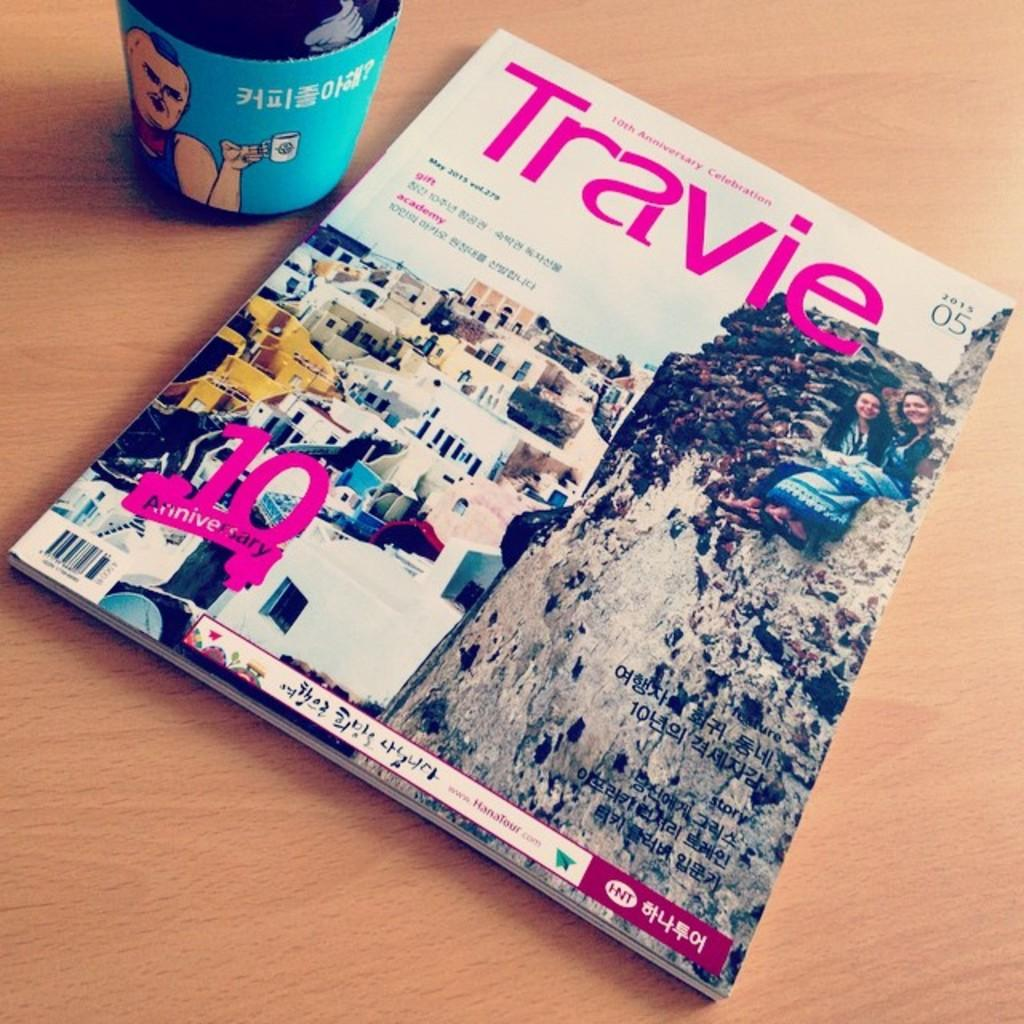<image>
Summarize the visual content of the image. Book titled Travie showing two woman sitting on a biulding. 